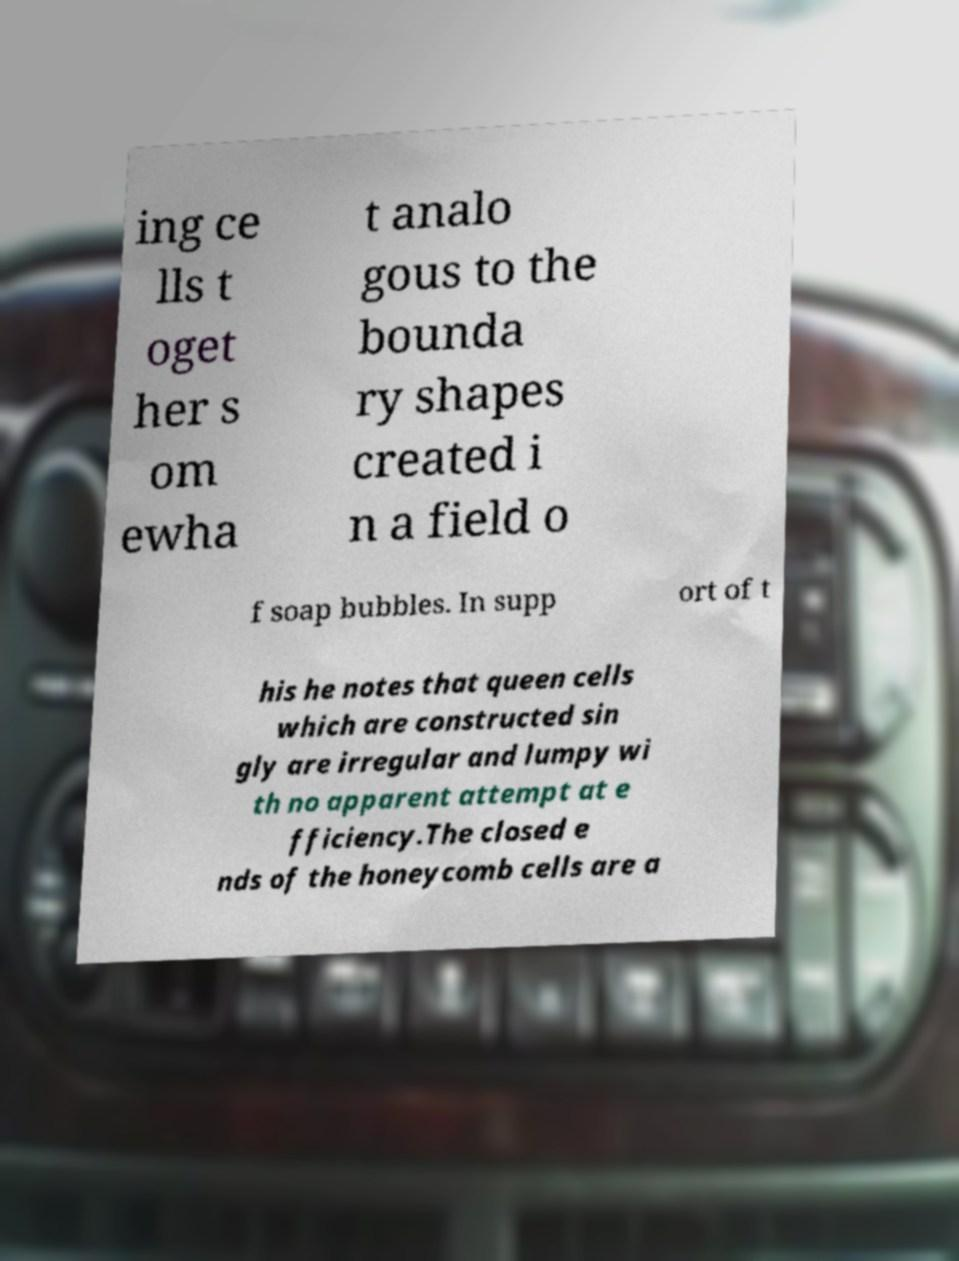Can you elaborate on what the analogy of 'soap bubbles' might signify in the context of the text? The analogy of 'soap bubbles' in the text likely refers to the efficiency and natural optimization found in the formation of soap bubbles, which are known for their minimal surface area for the volume they contain. Similarly, the text hints at a comparison with honeycomb cells, suggesting that nature optimizes the shapes and structures of biological constructs for efficiency, just as soap bubbles do. 